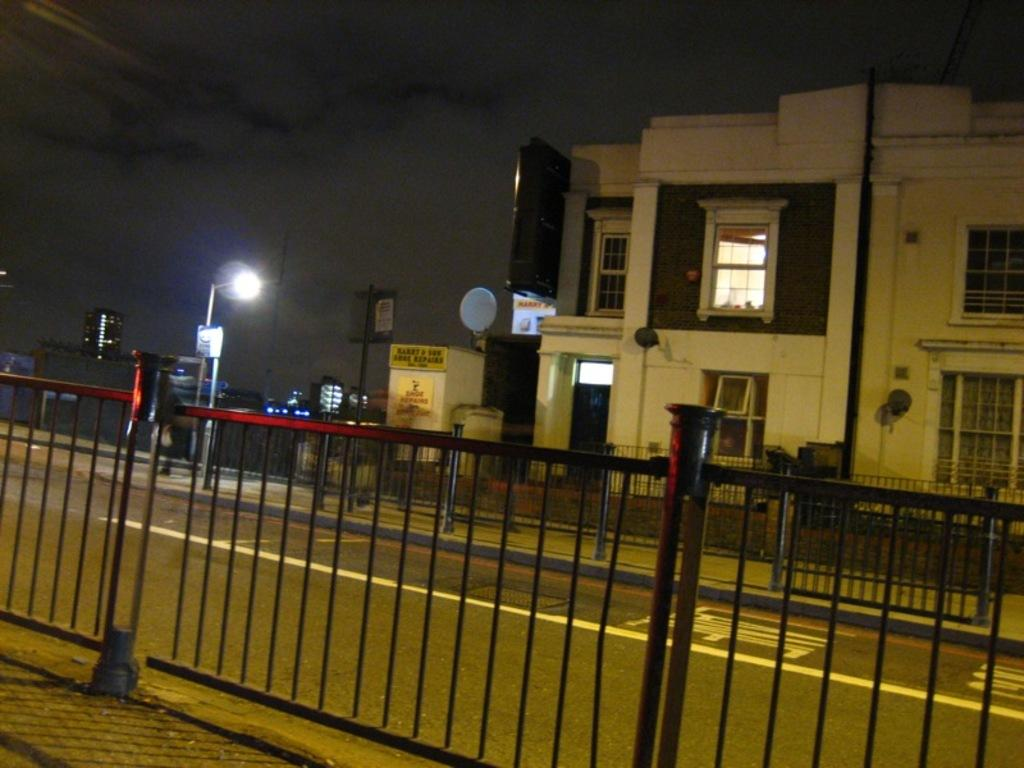What type of structures can be seen in the image? There are buildings in the image. What are the vertical supports in the image? There are poles in the image. What are the illuminating objects in the image? There are lights in the image. What are the flat, rectangular objects in the image? There are boards in the image. What is the net-like material in the image? There is a mesh in the image. What is the barrier-like object in the image? There is a railing in the image. What is the horizontal path in the image? There is a road at the bottom of the image. What is visible at the top of the image? There is sky visible at the top of the image. How many minutes does it take for the ring to reach the bait in the image? There is no ring or bait present in the image, so this question cannot be answered. 